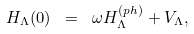Convert formula to latex. <formula><loc_0><loc_0><loc_500><loc_500>H _ { \Lambda } ( 0 ) \ = \ \omega H _ { \Lambda } ^ { ( p h ) } + V _ { \Lambda } ,</formula> 